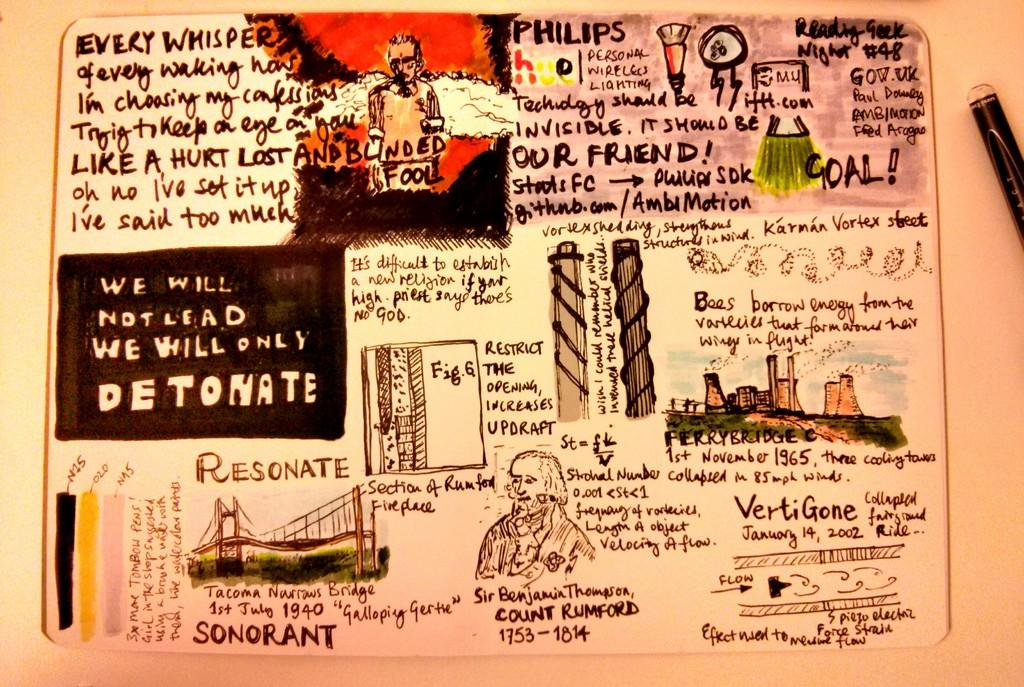What type of structures are depicted in the image? There is a sketch of buildings and a bridge in the image. Are there any human figures in the image? Yes, there are sketches of persons in the image. Is there any text or writing in the image? Yes, there is writing in the image. What type of farm animals can be seen in the image? There are no farm animals present in the image; it contains sketches of buildings, a bridge, persons, and writing. Can you describe the man shaking hands with someone in the image? There is no man shaking hands with someone in the image; it only contains sketches of buildings, a bridge, persons, and writing. 